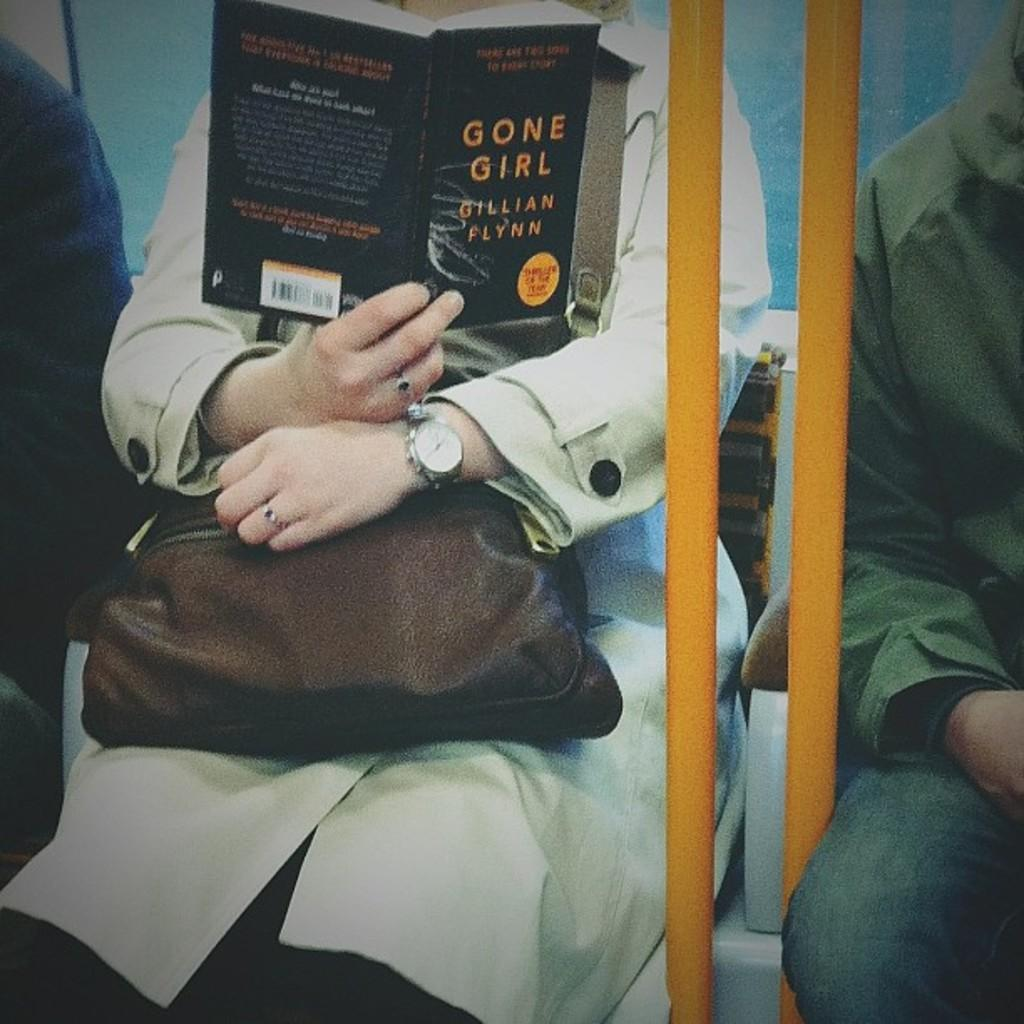<image>
Give a short and clear explanation of the subsequent image. a person on public transport reading Gone Girl 